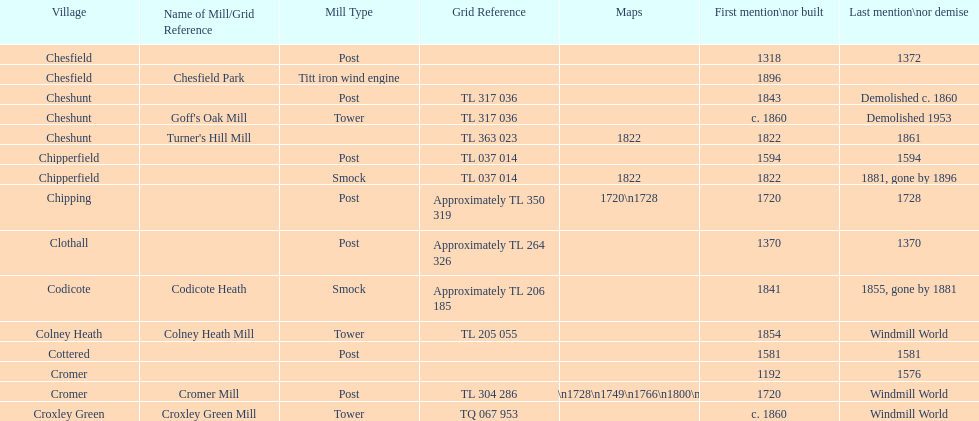How man "c" windmills have there been? 15. 